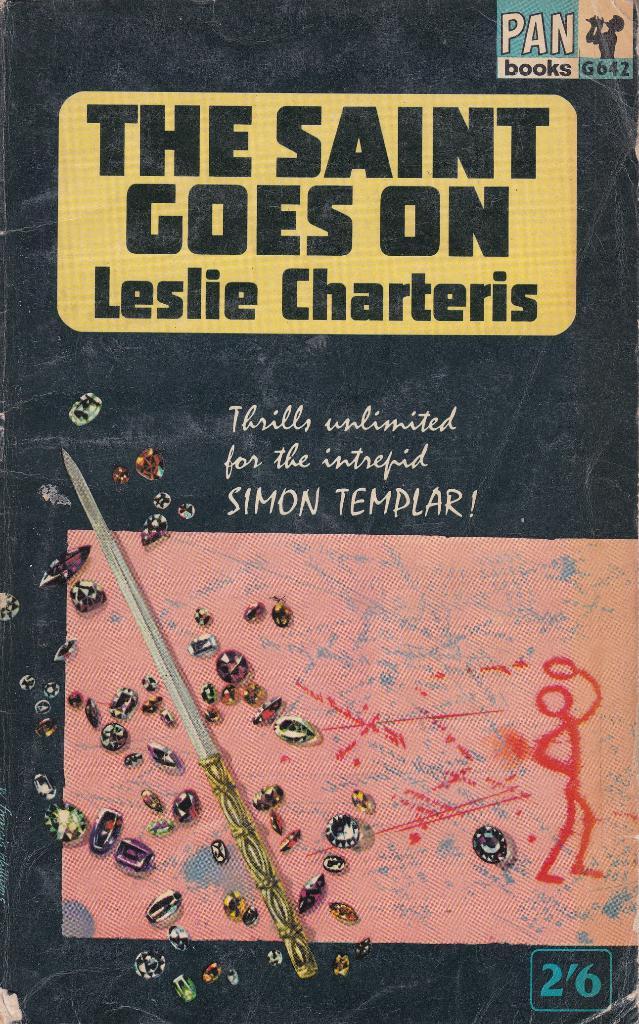What is the name of the book?
Provide a succinct answer. The saint goes on. Who does this book claim is intrepid?
Provide a short and direct response. Simon templar. 